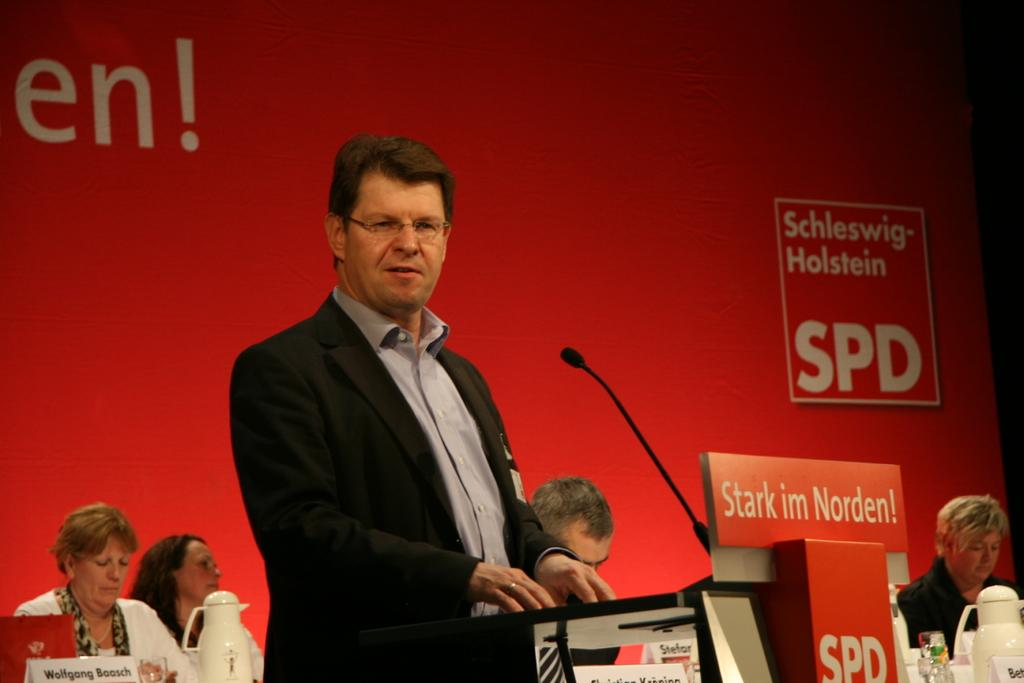What is the main subject in the image? There is a person standing in the image. What type of structure can be seen in the image? There is a wooden structure in the image. What color is the background of the image? The background of the image has a red backdrop. Can you see any sea creatures swimming in the image? There is no sea or sea creatures present in the image. What type of treatment is being administered to the person in the image? There is no treatment being administered to the person in the image; they are simply standing. 